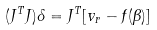Convert formula to latex. <formula><loc_0><loc_0><loc_500><loc_500>( J ^ { T } J ) \delta = J ^ { T } [ v _ { r } - f ( \beta ) ]</formula> 